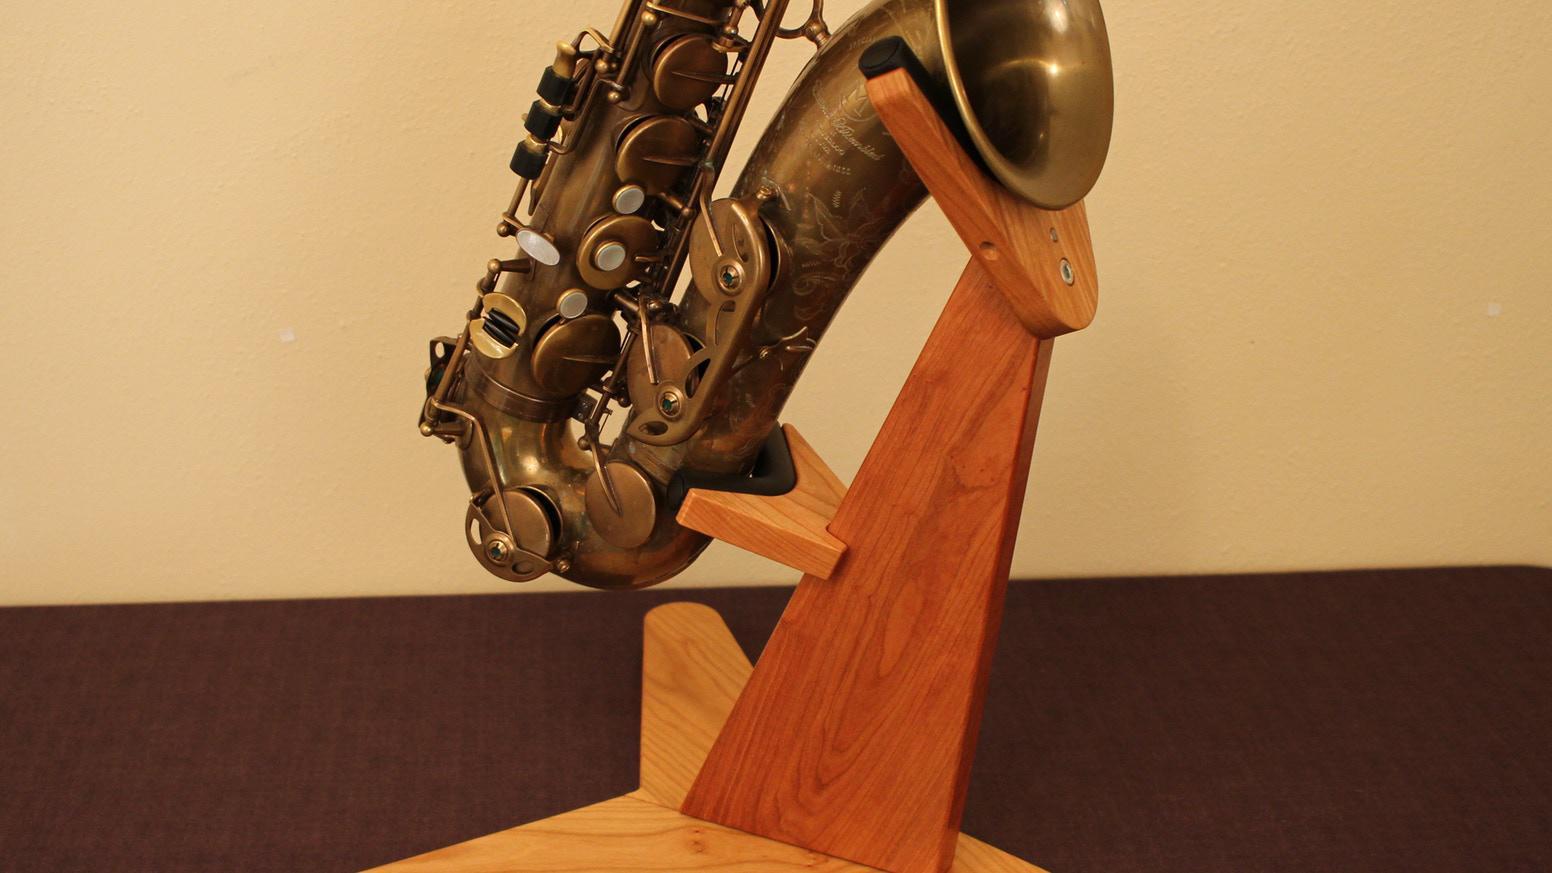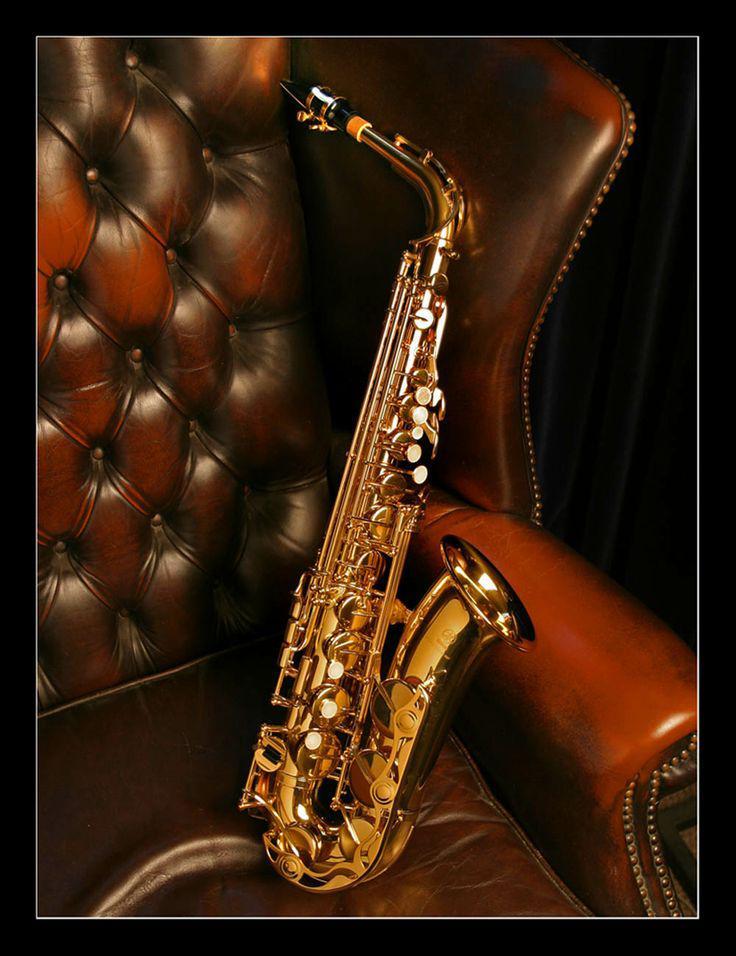The first image is the image on the left, the second image is the image on the right. For the images displayed, is the sentence "All the instruments are on a stand." factually correct? Answer yes or no. No. 